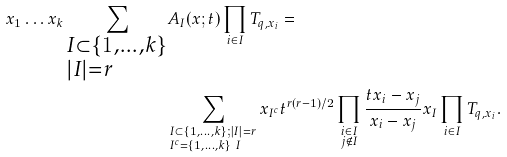<formula> <loc_0><loc_0><loc_500><loc_500>x _ { 1 } \dots x _ { k } \sum _ { \begin{subarray} { c } I \subset \{ 1 , \dots , k \} \\ | I | = r \end{subarray} } & A _ { I } ( x ; t ) \prod _ { i \in I } T _ { q , x _ { i } } = \\ & \sum _ { \begin{subarray} { c } I \subset \{ 1 , \dots , k \} ; | I | = r \\ I ^ { c } = \{ 1 , \dots , k \} \ I \end{subarray} } x _ { I ^ { c } } t ^ { r ( r - 1 ) / 2 } \prod _ { \begin{subarray} { c } i \in I \\ j \not \in I \end{subarray} } \frac { t x _ { i } - x _ { j } } { x _ { i } - x _ { j } } x _ { I } \prod _ { i \in I } T _ { q , x _ { i } } .</formula> 